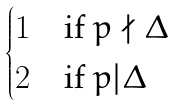Convert formula to latex. <formula><loc_0><loc_0><loc_500><loc_500>\begin{cases} 1 & \text {if} \ p \nmid \Delta \\ 2 & \text {if} \ p | \Delta \end{cases}</formula> 